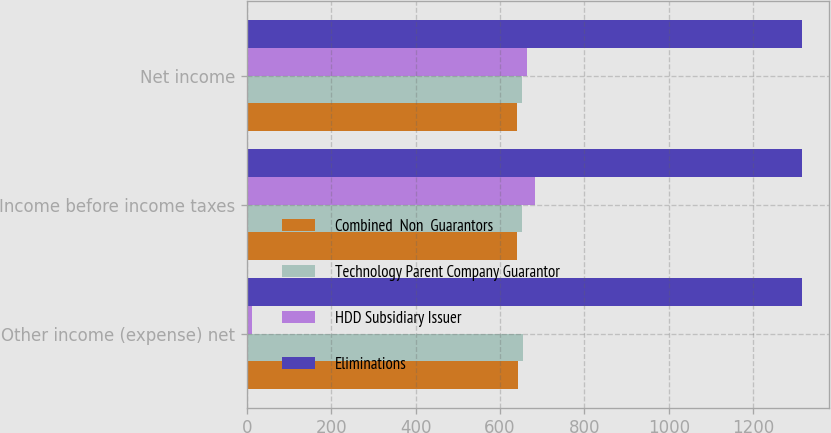<chart> <loc_0><loc_0><loc_500><loc_500><stacked_bar_chart><ecel><fcel>Other income (expense) net<fcel>Income before income taxes<fcel>Net income<nl><fcel>Combined  Non  Guarantors<fcel>642<fcel>641<fcel>641<nl><fcel>Technology Parent Company Guarantor<fcel>654<fcel>651<fcel>651<nl><fcel>HDD Subsidiary Issuer<fcel>12<fcel>683<fcel>664<nl><fcel>Eliminations<fcel>1315<fcel>1315<fcel>1315<nl></chart> 